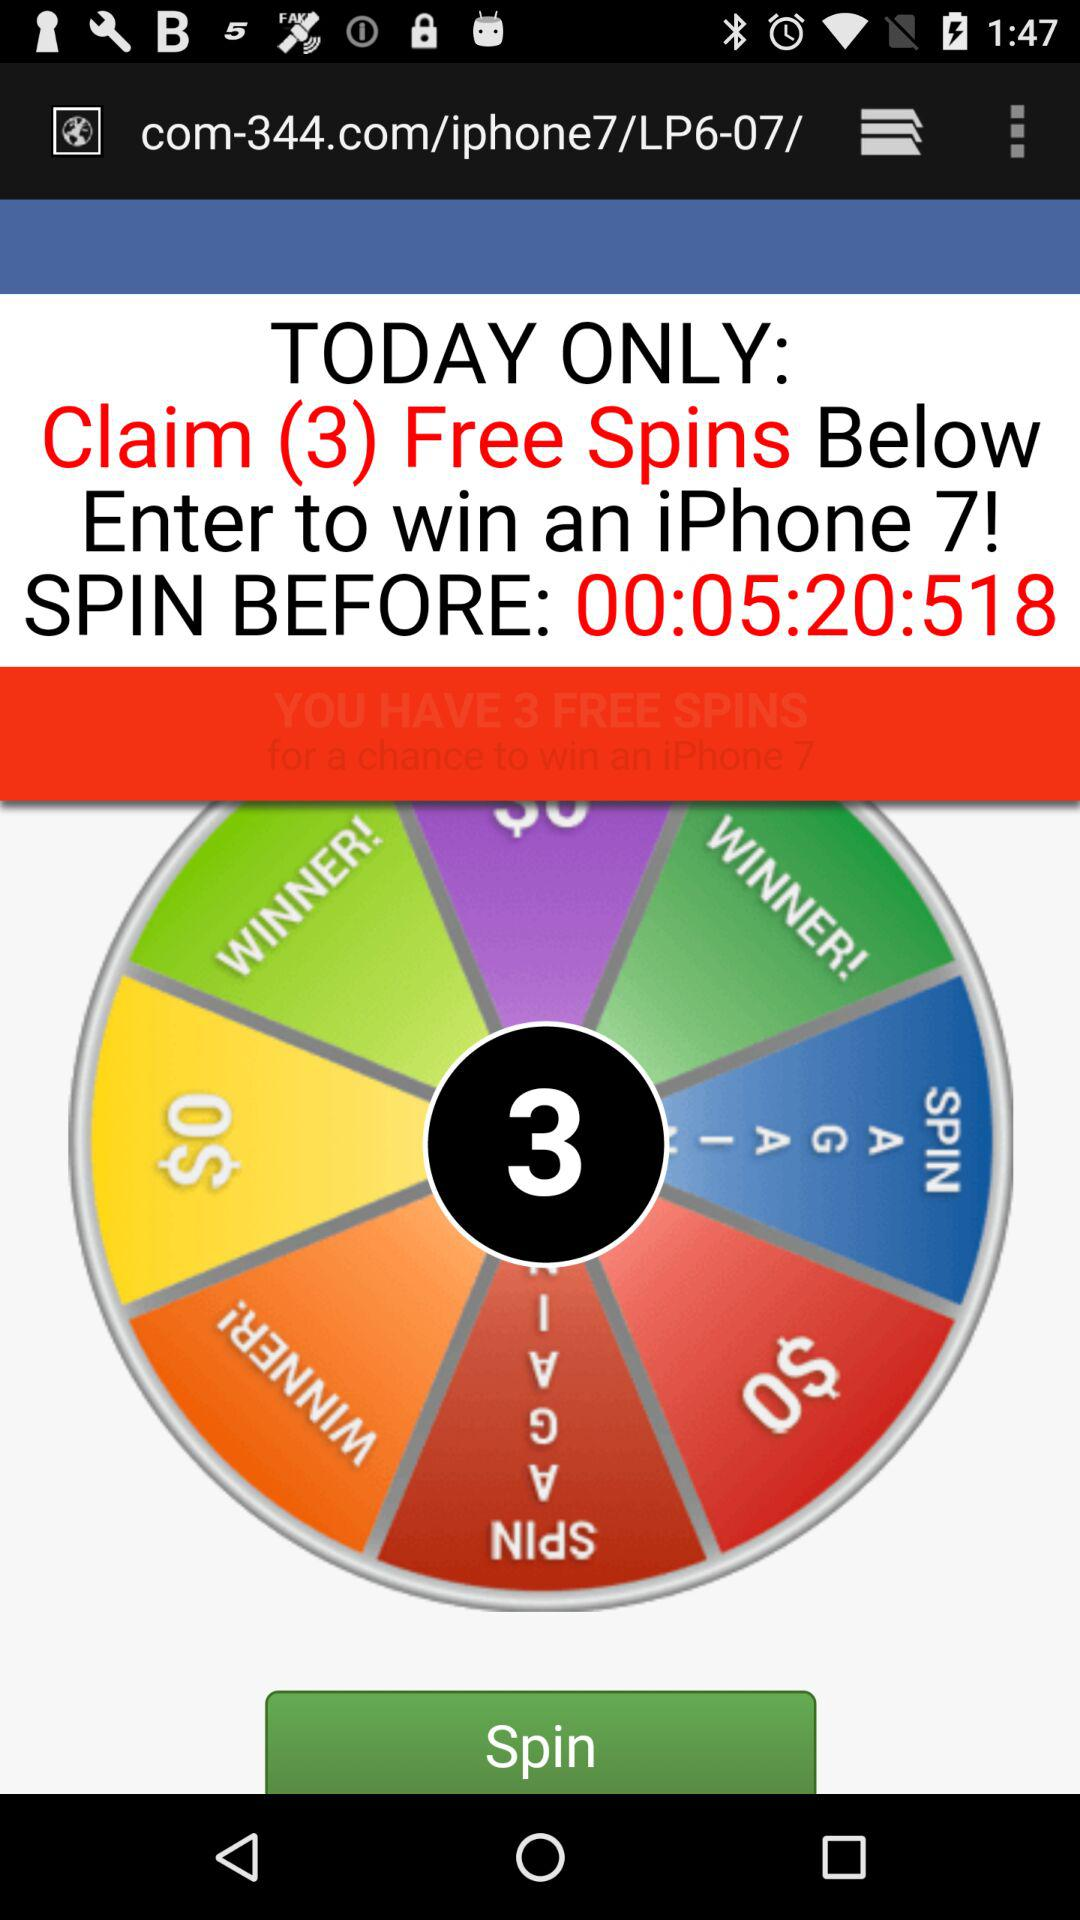How many free spins do I have left?
Answer the question using a single word or phrase. 3 